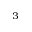Convert formula to latex. <formula><loc_0><loc_0><loc_500><loc_500>^ { 3 }</formula> 